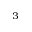Convert formula to latex. <formula><loc_0><loc_0><loc_500><loc_500>^ { 3 }</formula> 